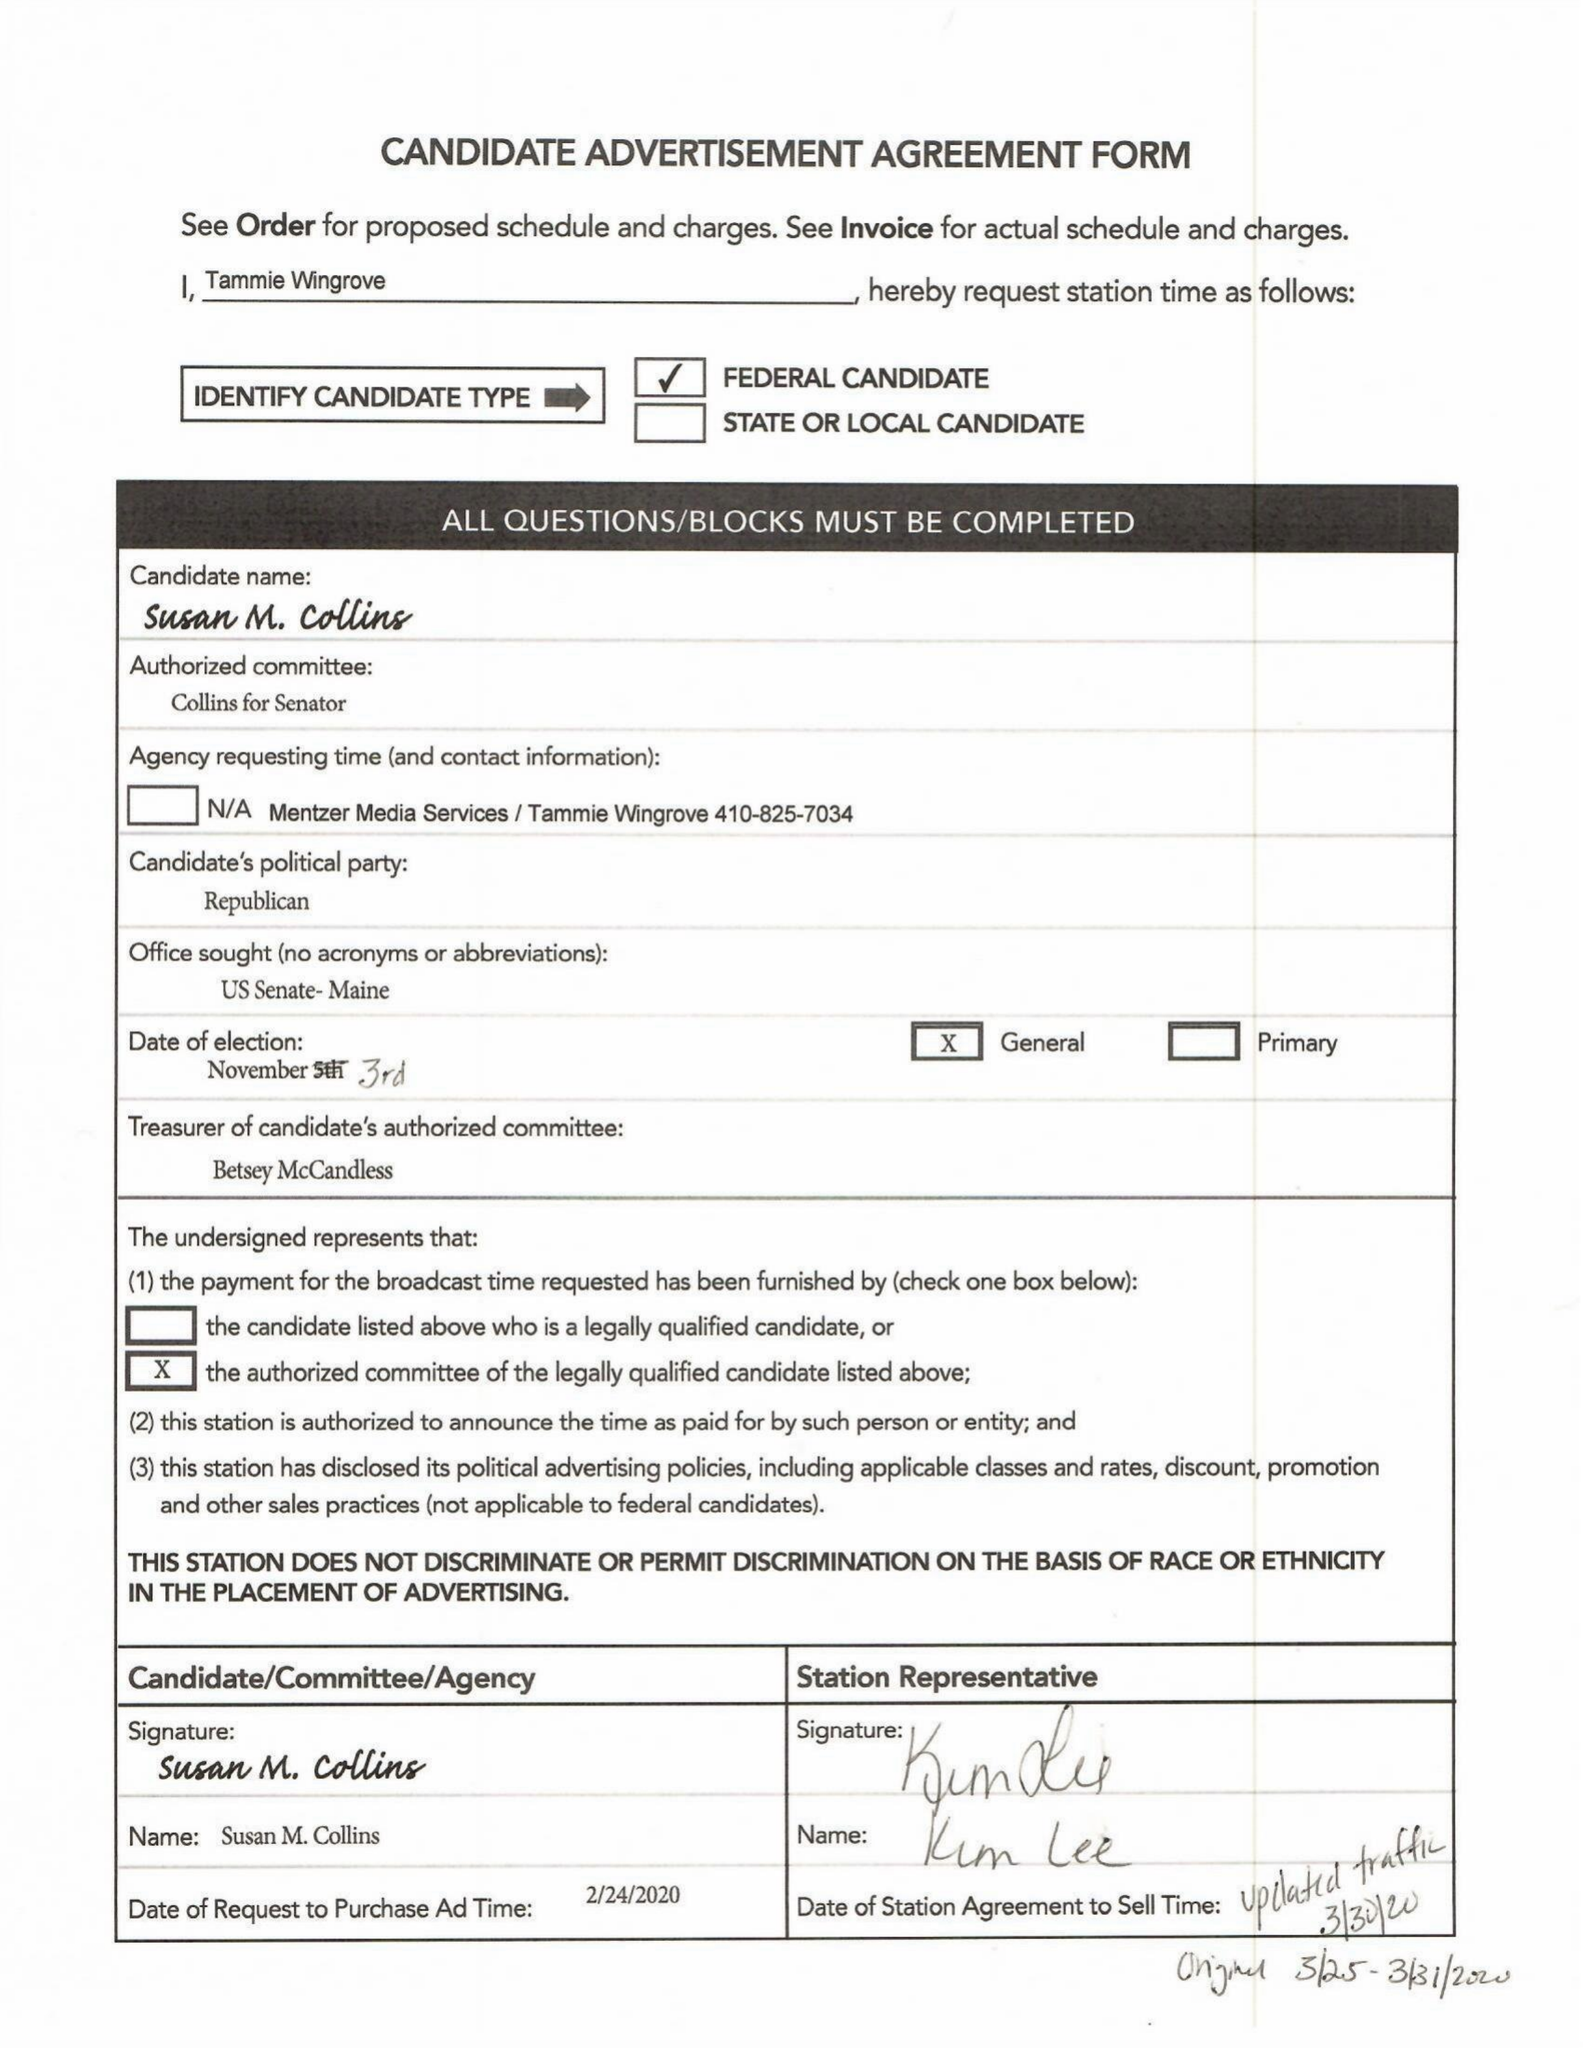What is the value for the contract_num?
Answer the question using a single word or phrase. 1562805 